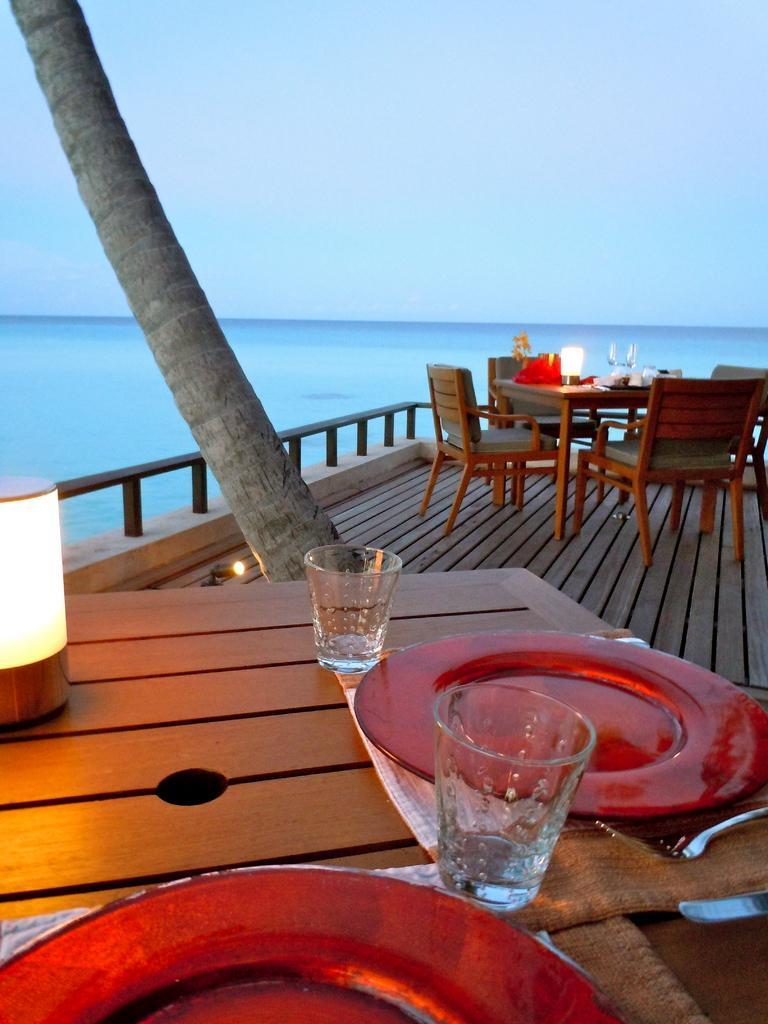Can you describe this image briefly? In this image I can see at the bottom there are glasses and plates on this dining table. On the left side it looks like a lamp. In the middle there is a bark of a tree, in the background there is water. At the top there is the sky. 